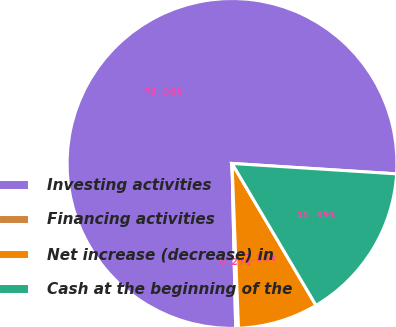Convert chart. <chart><loc_0><loc_0><loc_500><loc_500><pie_chart><fcel>Investing activities<fcel>Financing activities<fcel>Net increase (decrease) in<fcel>Cash at the beginning of the<nl><fcel>76.36%<fcel>0.27%<fcel>7.88%<fcel>15.49%<nl></chart> 